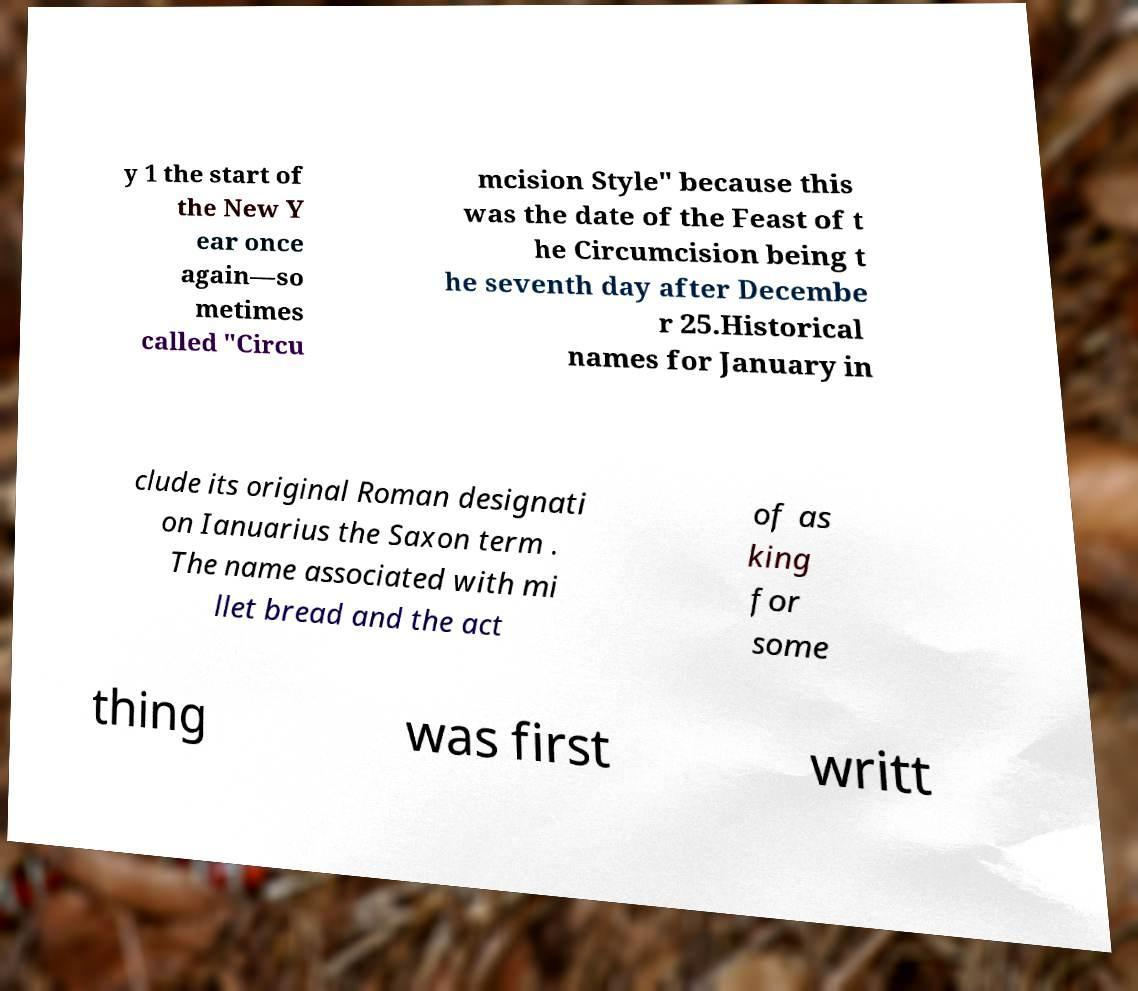I need the written content from this picture converted into text. Can you do that? y 1 the start of the New Y ear once again—so metimes called "Circu mcision Style" because this was the date of the Feast of t he Circumcision being t he seventh day after Decembe r 25.Historical names for January in clude its original Roman designati on Ianuarius the Saxon term . The name associated with mi llet bread and the act of as king for some thing was first writt 